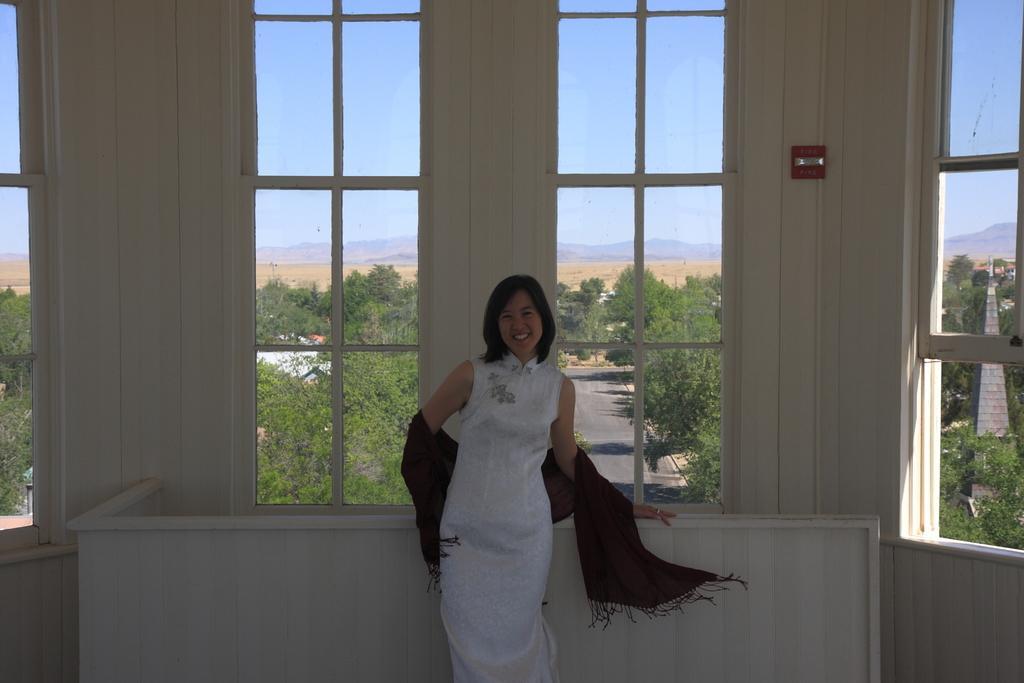Please provide a concise description of this image. In this picture I can see there is a woman standing and she is wearing a white dress and there are few windows in the backdrop and there is a road and there are trees visible from the window. 